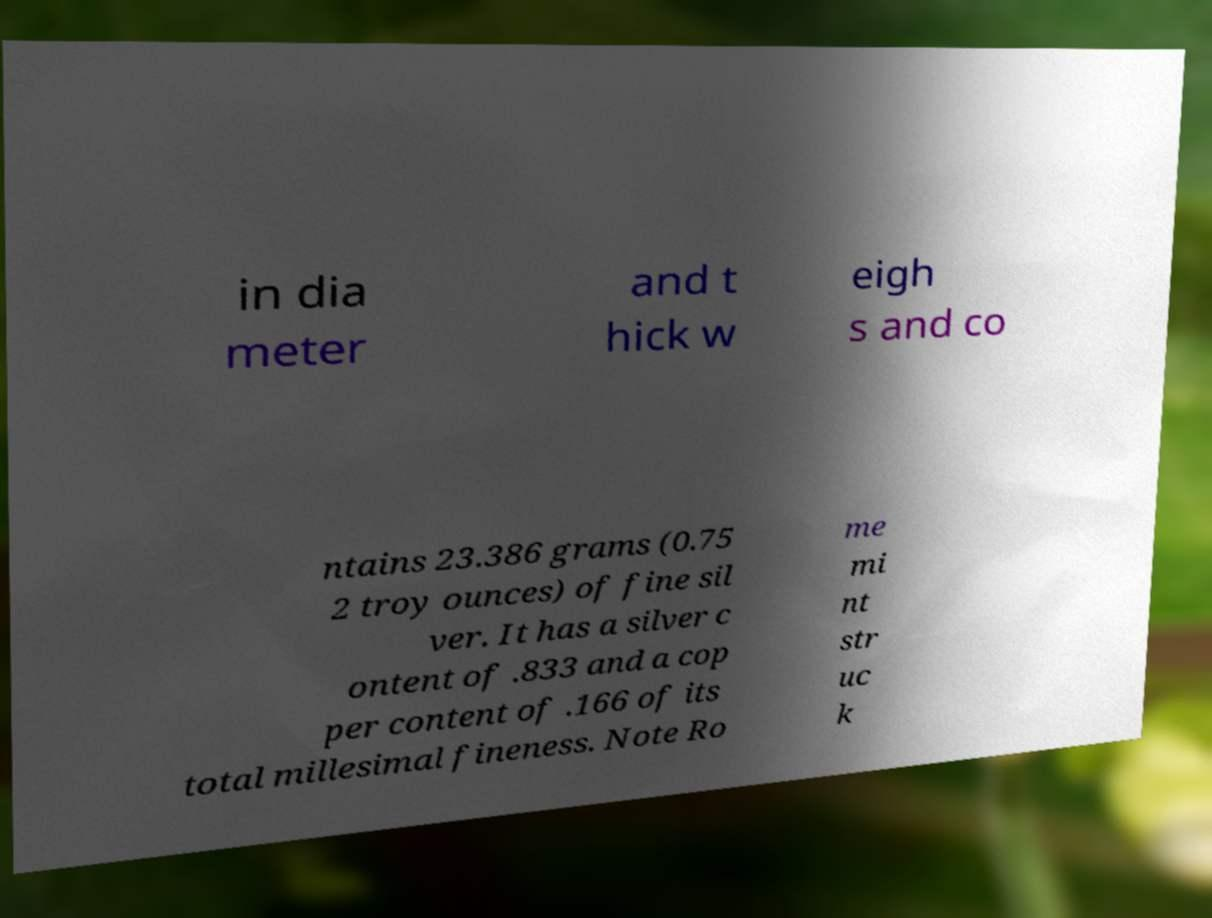Please identify and transcribe the text found in this image. in dia meter and t hick w eigh s and co ntains 23.386 grams (0.75 2 troy ounces) of fine sil ver. It has a silver c ontent of .833 and a cop per content of .166 of its total millesimal fineness. Note Ro me mi nt str uc k 